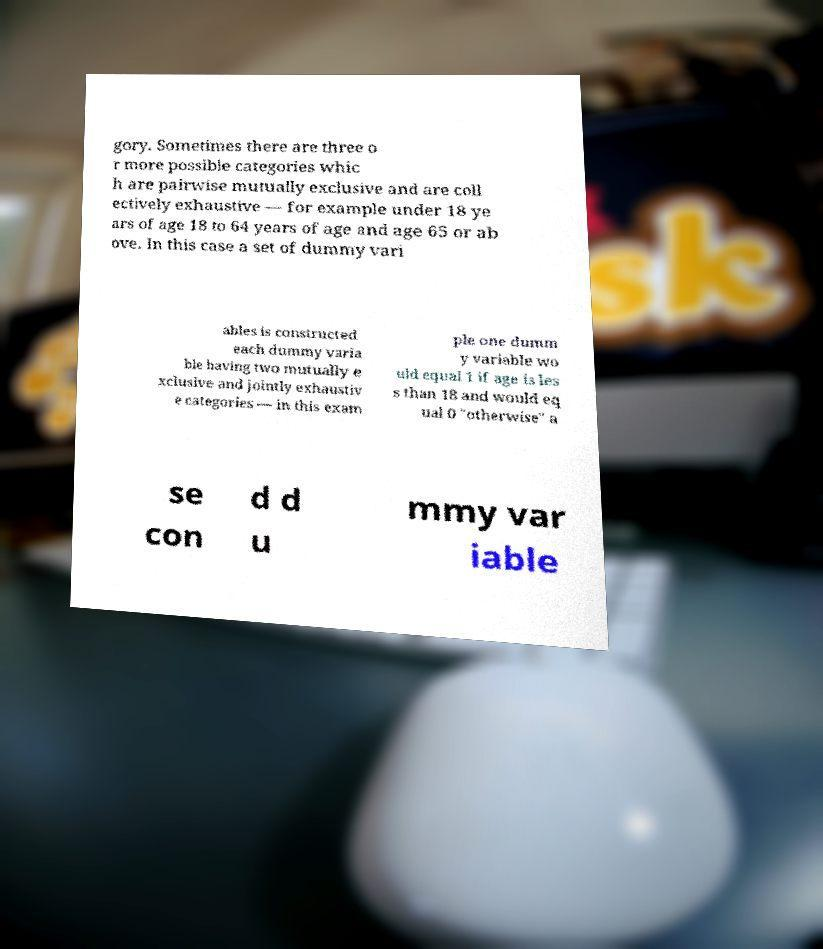Could you assist in decoding the text presented in this image and type it out clearly? gory. Sometimes there are three o r more possible categories whic h are pairwise mutually exclusive and are coll ectively exhaustive — for example under 18 ye ars of age 18 to 64 years of age and age 65 or ab ove. In this case a set of dummy vari ables is constructed each dummy varia ble having two mutually e xclusive and jointly exhaustiv e categories — in this exam ple one dumm y variable wo uld equal 1 if age is les s than 18 and would eq ual 0 "otherwise" a se con d d u mmy var iable 